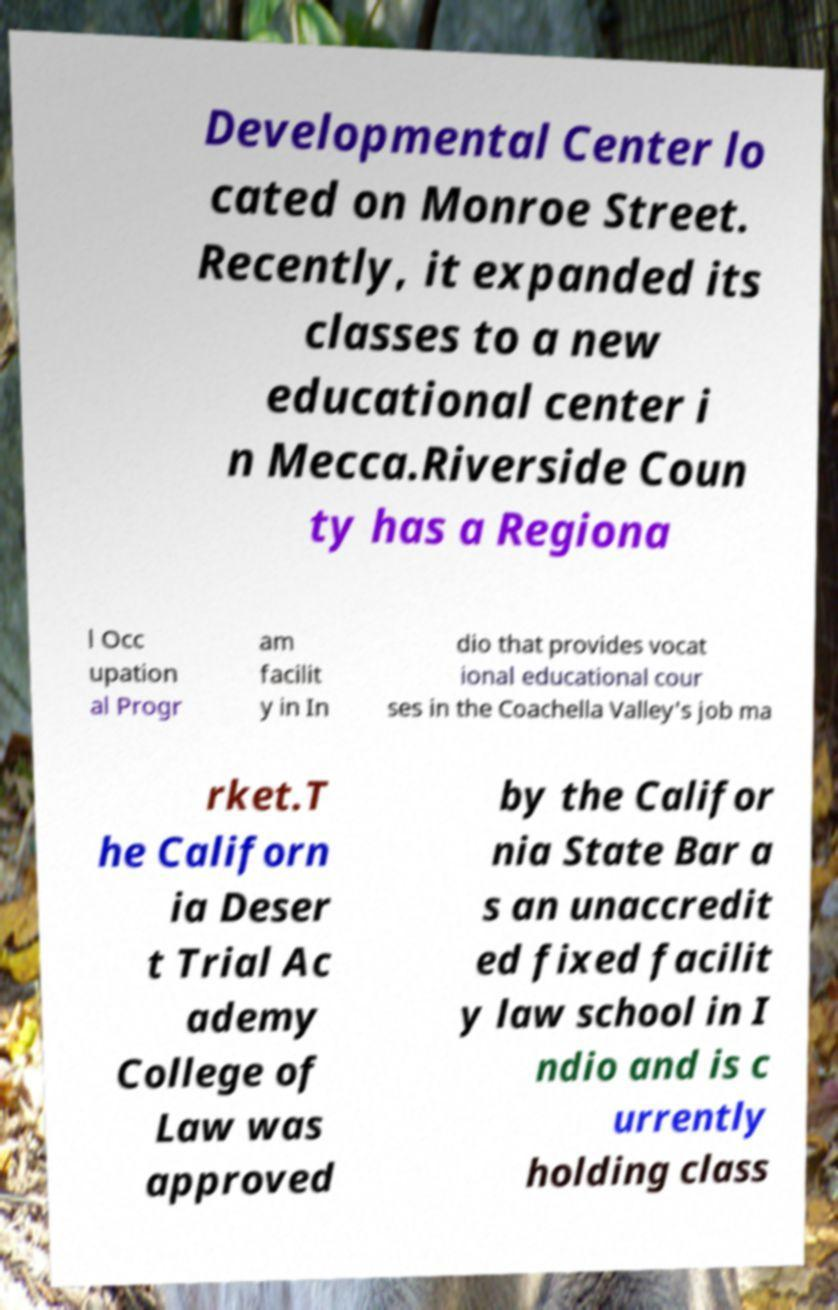Can you accurately transcribe the text from the provided image for me? Developmental Center lo cated on Monroe Street. Recently, it expanded its classes to a new educational center i n Mecca.Riverside Coun ty has a Regiona l Occ upation al Progr am facilit y in In dio that provides vocat ional educational cour ses in the Coachella Valley's job ma rket.T he Californ ia Deser t Trial Ac ademy College of Law was approved by the Califor nia State Bar a s an unaccredit ed fixed facilit y law school in I ndio and is c urrently holding class 